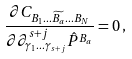<formula> <loc_0><loc_0><loc_500><loc_500>\frac { \partial C _ { B _ { 1 } \dots \widetilde { B _ { a } } \dots B _ { N } } } { \partial \partial ^ { s + j } _ { \gamma _ { 1 } \dots \gamma _ { s + j } } \hat { P } ^ { B _ { a } } } = 0 \, ,</formula> 